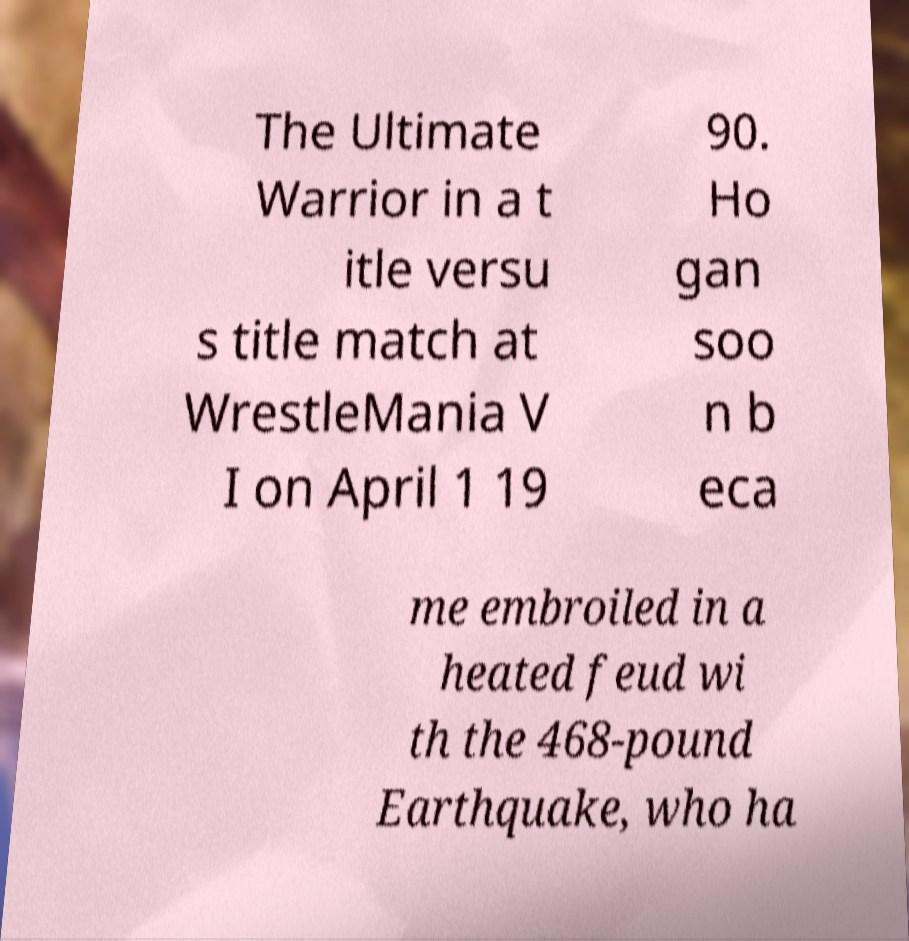Can you read and provide the text displayed in the image?This photo seems to have some interesting text. Can you extract and type it out for me? The Ultimate Warrior in a t itle versu s title match at WrestleMania V I on April 1 19 90. Ho gan soo n b eca me embroiled in a heated feud wi th the 468-pound Earthquake, who ha 